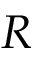<formula> <loc_0><loc_0><loc_500><loc_500>R</formula> 